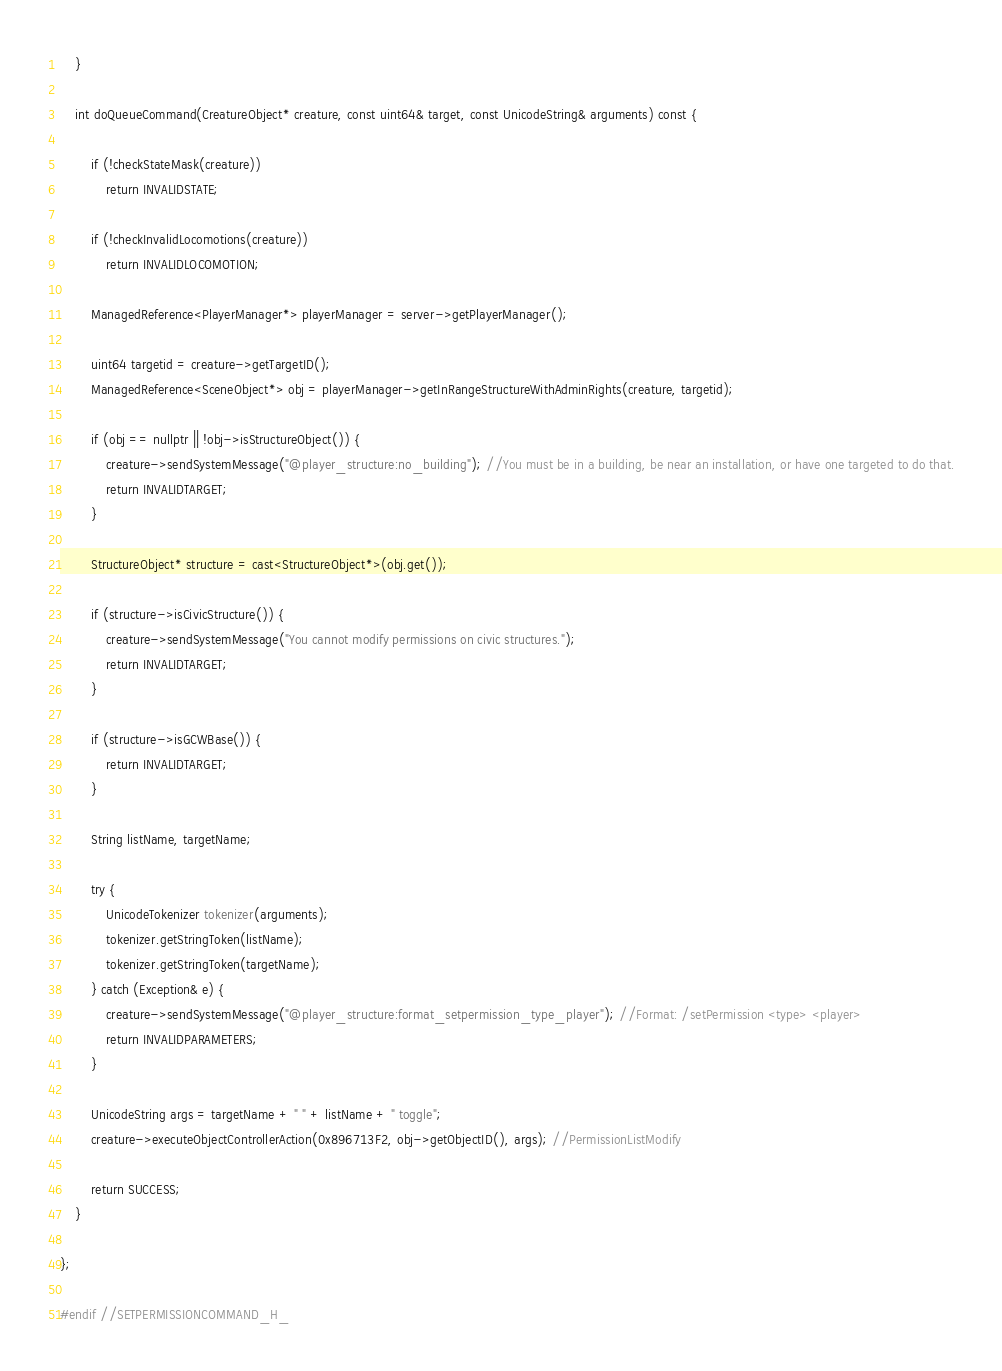Convert code to text. <code><loc_0><loc_0><loc_500><loc_500><_C_>
	}

	int doQueueCommand(CreatureObject* creature, const uint64& target, const UnicodeString& arguments) const {

		if (!checkStateMask(creature))
			return INVALIDSTATE;

		if (!checkInvalidLocomotions(creature))
			return INVALIDLOCOMOTION;

		ManagedReference<PlayerManager*> playerManager = server->getPlayerManager();

		uint64 targetid = creature->getTargetID();
		ManagedReference<SceneObject*> obj = playerManager->getInRangeStructureWithAdminRights(creature, targetid);

		if (obj == nullptr || !obj->isStructureObject()) {
			creature->sendSystemMessage("@player_structure:no_building"); //You must be in a building, be near an installation, or have one targeted to do that.
			return INVALIDTARGET;
		}

		StructureObject* structure = cast<StructureObject*>(obj.get());

		if (structure->isCivicStructure()) {
			creature->sendSystemMessage("You cannot modify permissions on civic structures.");
			return INVALIDTARGET;
		}

		if (structure->isGCWBase()) {
			return INVALIDTARGET;
		}

		String listName, targetName;

		try {
			UnicodeTokenizer tokenizer(arguments);
			tokenizer.getStringToken(listName);
			tokenizer.getStringToken(targetName);
		} catch (Exception& e) {
			creature->sendSystemMessage("@player_structure:format_setpermission_type_player"); //Format: /setPermission <type> <player>
			return INVALIDPARAMETERS;
		}

		UnicodeString args = targetName + " " + listName + " toggle";
		creature->executeObjectControllerAction(0x896713F2, obj->getObjectID(), args); //PermissionListModify

		return SUCCESS;
	}

};

#endif //SETPERMISSIONCOMMAND_H_
</code> 